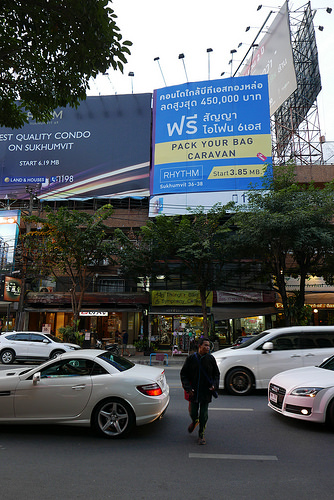<image>
Is the man behind the car? No. The man is not behind the car. From this viewpoint, the man appears to be positioned elsewhere in the scene. Is there a man in front of the car? No. The man is not in front of the car. The spatial positioning shows a different relationship between these objects. 